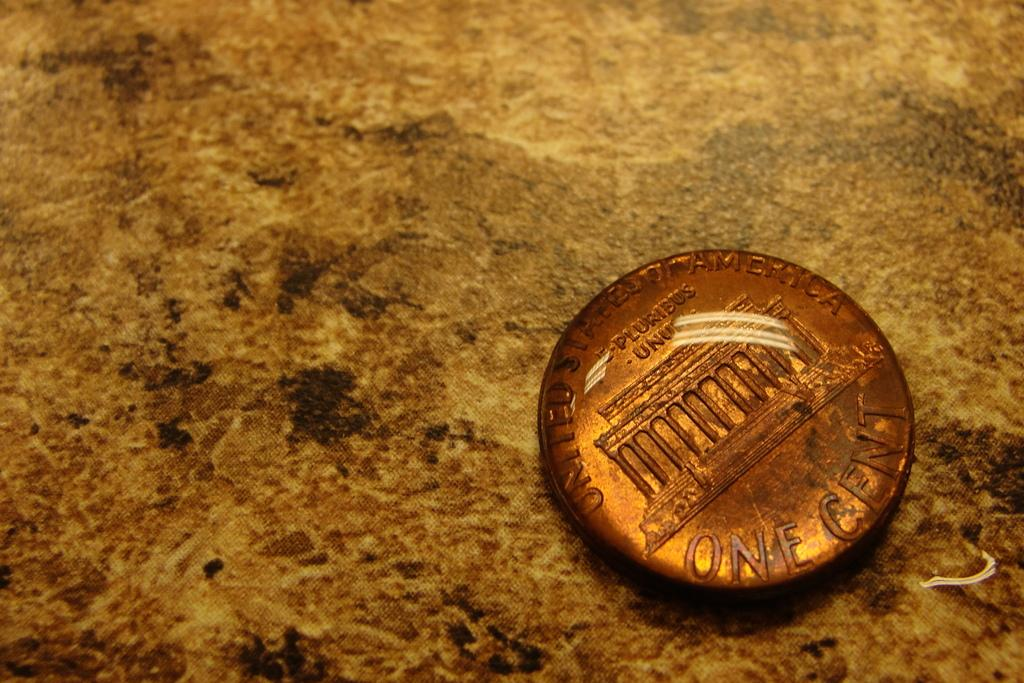<image>
Give a short and clear explanation of the subsequent image. the back side of a ONE CENT piece on a marble surface 